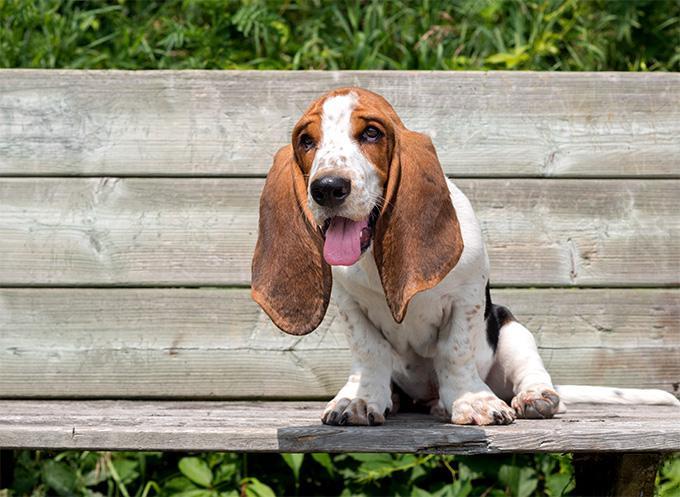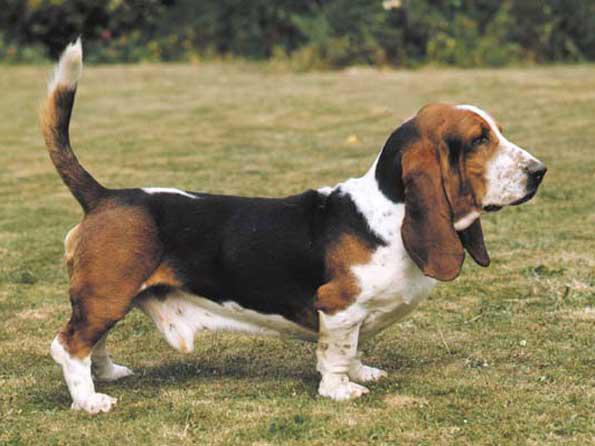The first image is the image on the left, the second image is the image on the right. For the images displayed, is the sentence "One of the images shows a dog on a bench." factually correct? Answer yes or no. Yes. 